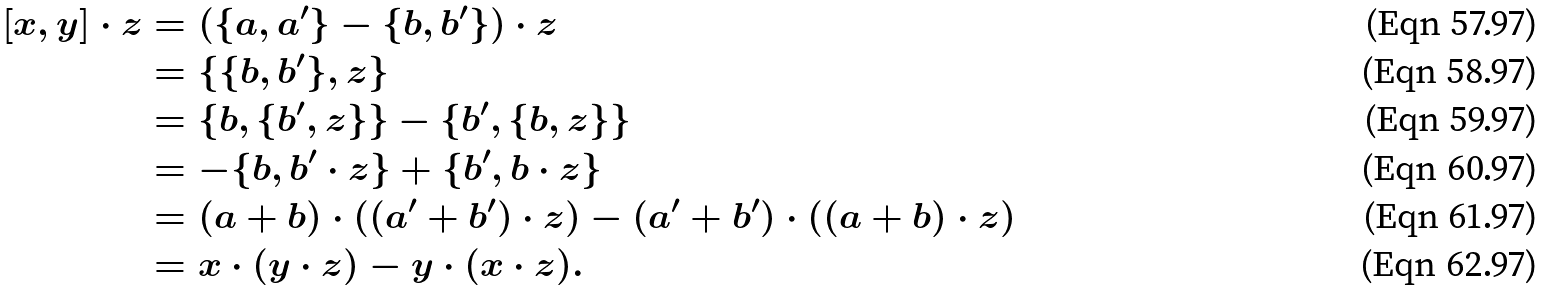<formula> <loc_0><loc_0><loc_500><loc_500>[ x , y ] \cdot z & = ( \{ a , a ^ { \prime } \} - \{ b , b ^ { \prime } \} ) \cdot z \\ & = \{ \{ b , b ^ { \prime } \} , z \} \\ & = \{ b , \{ b ^ { \prime } , z \} \} - \{ b ^ { \prime } , \{ b , z \} \} \\ & = - \{ b , b ^ { \prime } \cdot z \} + \{ b ^ { \prime } , b \cdot z \} \\ & = ( a + b ) \cdot ( ( a ^ { \prime } + b ^ { \prime } ) \cdot z ) - ( a ^ { \prime } + b ^ { \prime } ) \cdot ( ( a + b ) \cdot z ) \\ & = x \cdot ( y \cdot z ) - y \cdot ( x \cdot z ) .</formula> 